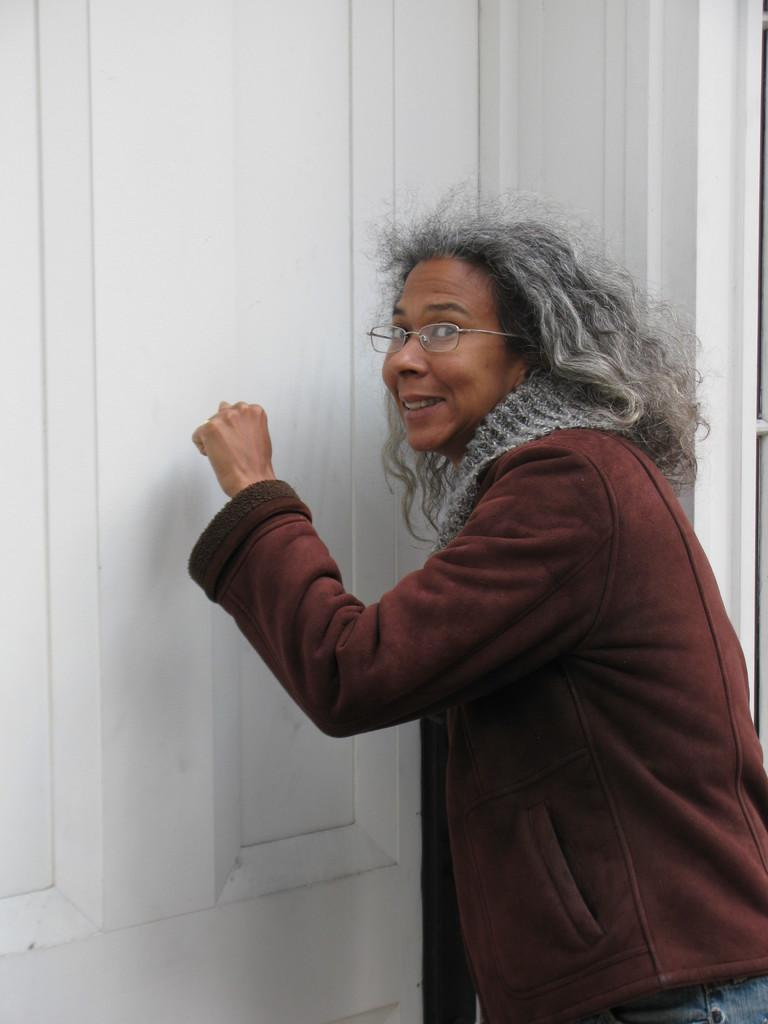Who is present in the image? There is a person in the image. What is the person doing in the image? The person is standing. What accessory is the person wearing in the image? The person is wearing spectacles. What can be seen in the background of the image? There is a door in the background of the image. What does the person in the image hate the most? There is no information about the person's feelings or preferences in the image, so it cannot be determined what they might hate. 